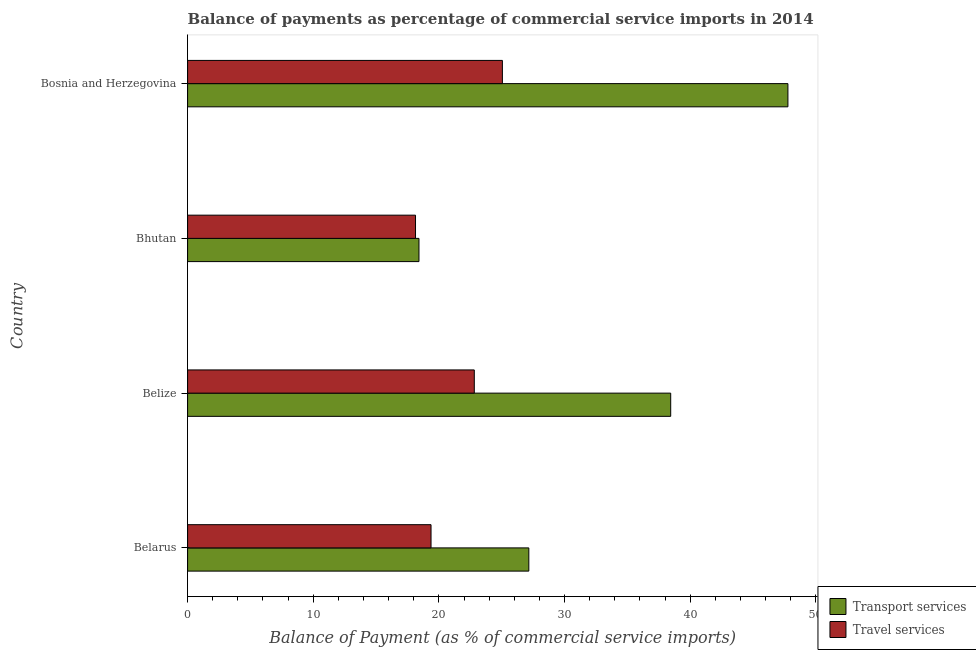How many different coloured bars are there?
Your answer should be very brief. 2. Are the number of bars per tick equal to the number of legend labels?
Your response must be concise. Yes. How many bars are there on the 4th tick from the top?
Ensure brevity in your answer.  2. How many bars are there on the 4th tick from the bottom?
Provide a short and direct response. 2. What is the label of the 3rd group of bars from the top?
Your answer should be compact. Belize. What is the balance of payments of transport services in Bosnia and Herzegovina?
Your answer should be very brief. 47.78. Across all countries, what is the maximum balance of payments of travel services?
Provide a short and direct response. 25.05. Across all countries, what is the minimum balance of payments of transport services?
Provide a short and direct response. 18.41. In which country was the balance of payments of transport services maximum?
Keep it short and to the point. Bosnia and Herzegovina. In which country was the balance of payments of transport services minimum?
Offer a terse response. Bhutan. What is the total balance of payments of transport services in the graph?
Offer a very short reply. 131.79. What is the difference between the balance of payments of transport services in Belarus and that in Bhutan?
Make the answer very short. 8.74. What is the difference between the balance of payments of transport services in Bhutan and the balance of payments of travel services in Bosnia and Herzegovina?
Your answer should be very brief. -6.64. What is the average balance of payments of travel services per country?
Provide a short and direct response. 21.34. What is the difference between the balance of payments of travel services and balance of payments of transport services in Belize?
Your answer should be very brief. -15.63. In how many countries, is the balance of payments of transport services greater than 18 %?
Offer a very short reply. 4. What is the ratio of the balance of payments of travel services in Belize to that in Bosnia and Herzegovina?
Your answer should be compact. 0.91. Is the difference between the balance of payments of travel services in Belize and Bosnia and Herzegovina greater than the difference between the balance of payments of transport services in Belize and Bosnia and Herzegovina?
Your response must be concise. Yes. What is the difference between the highest and the second highest balance of payments of travel services?
Provide a succinct answer. 2.24. What is the difference between the highest and the lowest balance of payments of transport services?
Offer a very short reply. 29.36. What does the 2nd bar from the top in Bhutan represents?
Ensure brevity in your answer.  Transport services. What does the 1st bar from the bottom in Bhutan represents?
Your response must be concise. Transport services. Are all the bars in the graph horizontal?
Give a very brief answer. Yes. Are the values on the major ticks of X-axis written in scientific E-notation?
Offer a terse response. No. Does the graph contain grids?
Provide a short and direct response. No. Where does the legend appear in the graph?
Provide a short and direct response. Bottom right. How many legend labels are there?
Give a very brief answer. 2. What is the title of the graph?
Provide a succinct answer. Balance of payments as percentage of commercial service imports in 2014. What is the label or title of the X-axis?
Offer a terse response. Balance of Payment (as % of commercial service imports). What is the Balance of Payment (as % of commercial service imports) in Transport services in Belarus?
Your answer should be compact. 27.16. What is the Balance of Payment (as % of commercial service imports) of Travel services in Belarus?
Your answer should be very brief. 19.37. What is the Balance of Payment (as % of commercial service imports) in Transport services in Belize?
Give a very brief answer. 38.45. What is the Balance of Payment (as % of commercial service imports) of Travel services in Belize?
Ensure brevity in your answer.  22.82. What is the Balance of Payment (as % of commercial service imports) in Transport services in Bhutan?
Ensure brevity in your answer.  18.41. What is the Balance of Payment (as % of commercial service imports) of Travel services in Bhutan?
Offer a very short reply. 18.14. What is the Balance of Payment (as % of commercial service imports) in Transport services in Bosnia and Herzegovina?
Provide a short and direct response. 47.78. What is the Balance of Payment (as % of commercial service imports) of Travel services in Bosnia and Herzegovina?
Provide a succinct answer. 25.05. Across all countries, what is the maximum Balance of Payment (as % of commercial service imports) in Transport services?
Your answer should be compact. 47.78. Across all countries, what is the maximum Balance of Payment (as % of commercial service imports) in Travel services?
Ensure brevity in your answer.  25.05. Across all countries, what is the minimum Balance of Payment (as % of commercial service imports) in Transport services?
Your response must be concise. 18.41. Across all countries, what is the minimum Balance of Payment (as % of commercial service imports) in Travel services?
Offer a very short reply. 18.14. What is the total Balance of Payment (as % of commercial service imports) in Transport services in the graph?
Provide a succinct answer. 131.79. What is the total Balance of Payment (as % of commercial service imports) of Travel services in the graph?
Keep it short and to the point. 85.38. What is the difference between the Balance of Payment (as % of commercial service imports) in Transport services in Belarus and that in Belize?
Provide a short and direct response. -11.29. What is the difference between the Balance of Payment (as % of commercial service imports) in Travel services in Belarus and that in Belize?
Ensure brevity in your answer.  -3.44. What is the difference between the Balance of Payment (as % of commercial service imports) of Transport services in Belarus and that in Bhutan?
Make the answer very short. 8.74. What is the difference between the Balance of Payment (as % of commercial service imports) of Travel services in Belarus and that in Bhutan?
Offer a very short reply. 1.23. What is the difference between the Balance of Payment (as % of commercial service imports) of Transport services in Belarus and that in Bosnia and Herzegovina?
Offer a terse response. -20.62. What is the difference between the Balance of Payment (as % of commercial service imports) in Travel services in Belarus and that in Bosnia and Herzegovina?
Provide a short and direct response. -5.68. What is the difference between the Balance of Payment (as % of commercial service imports) in Transport services in Belize and that in Bhutan?
Your response must be concise. 20.03. What is the difference between the Balance of Payment (as % of commercial service imports) of Travel services in Belize and that in Bhutan?
Keep it short and to the point. 4.68. What is the difference between the Balance of Payment (as % of commercial service imports) of Transport services in Belize and that in Bosnia and Herzegovina?
Keep it short and to the point. -9.33. What is the difference between the Balance of Payment (as % of commercial service imports) of Travel services in Belize and that in Bosnia and Herzegovina?
Provide a succinct answer. -2.24. What is the difference between the Balance of Payment (as % of commercial service imports) in Transport services in Bhutan and that in Bosnia and Herzegovina?
Your answer should be compact. -29.36. What is the difference between the Balance of Payment (as % of commercial service imports) in Travel services in Bhutan and that in Bosnia and Herzegovina?
Your response must be concise. -6.91. What is the difference between the Balance of Payment (as % of commercial service imports) in Transport services in Belarus and the Balance of Payment (as % of commercial service imports) in Travel services in Belize?
Provide a short and direct response. 4.34. What is the difference between the Balance of Payment (as % of commercial service imports) in Transport services in Belarus and the Balance of Payment (as % of commercial service imports) in Travel services in Bhutan?
Provide a short and direct response. 9.02. What is the difference between the Balance of Payment (as % of commercial service imports) in Transport services in Belarus and the Balance of Payment (as % of commercial service imports) in Travel services in Bosnia and Herzegovina?
Your answer should be compact. 2.1. What is the difference between the Balance of Payment (as % of commercial service imports) of Transport services in Belize and the Balance of Payment (as % of commercial service imports) of Travel services in Bhutan?
Ensure brevity in your answer.  20.31. What is the difference between the Balance of Payment (as % of commercial service imports) of Transport services in Belize and the Balance of Payment (as % of commercial service imports) of Travel services in Bosnia and Herzegovina?
Your answer should be very brief. 13.39. What is the difference between the Balance of Payment (as % of commercial service imports) in Transport services in Bhutan and the Balance of Payment (as % of commercial service imports) in Travel services in Bosnia and Herzegovina?
Offer a terse response. -6.64. What is the average Balance of Payment (as % of commercial service imports) in Transport services per country?
Give a very brief answer. 32.95. What is the average Balance of Payment (as % of commercial service imports) of Travel services per country?
Provide a short and direct response. 21.35. What is the difference between the Balance of Payment (as % of commercial service imports) of Transport services and Balance of Payment (as % of commercial service imports) of Travel services in Belarus?
Provide a short and direct response. 7.78. What is the difference between the Balance of Payment (as % of commercial service imports) of Transport services and Balance of Payment (as % of commercial service imports) of Travel services in Belize?
Make the answer very short. 15.63. What is the difference between the Balance of Payment (as % of commercial service imports) in Transport services and Balance of Payment (as % of commercial service imports) in Travel services in Bhutan?
Offer a very short reply. 0.27. What is the difference between the Balance of Payment (as % of commercial service imports) in Transport services and Balance of Payment (as % of commercial service imports) in Travel services in Bosnia and Herzegovina?
Your response must be concise. 22.72. What is the ratio of the Balance of Payment (as % of commercial service imports) in Transport services in Belarus to that in Belize?
Keep it short and to the point. 0.71. What is the ratio of the Balance of Payment (as % of commercial service imports) in Travel services in Belarus to that in Belize?
Give a very brief answer. 0.85. What is the ratio of the Balance of Payment (as % of commercial service imports) of Transport services in Belarus to that in Bhutan?
Offer a terse response. 1.47. What is the ratio of the Balance of Payment (as % of commercial service imports) of Travel services in Belarus to that in Bhutan?
Your answer should be compact. 1.07. What is the ratio of the Balance of Payment (as % of commercial service imports) of Transport services in Belarus to that in Bosnia and Herzegovina?
Offer a terse response. 0.57. What is the ratio of the Balance of Payment (as % of commercial service imports) in Travel services in Belarus to that in Bosnia and Herzegovina?
Your answer should be very brief. 0.77. What is the ratio of the Balance of Payment (as % of commercial service imports) of Transport services in Belize to that in Bhutan?
Provide a succinct answer. 2.09. What is the ratio of the Balance of Payment (as % of commercial service imports) in Travel services in Belize to that in Bhutan?
Ensure brevity in your answer.  1.26. What is the ratio of the Balance of Payment (as % of commercial service imports) of Transport services in Belize to that in Bosnia and Herzegovina?
Your response must be concise. 0.8. What is the ratio of the Balance of Payment (as % of commercial service imports) in Travel services in Belize to that in Bosnia and Herzegovina?
Keep it short and to the point. 0.91. What is the ratio of the Balance of Payment (as % of commercial service imports) in Transport services in Bhutan to that in Bosnia and Herzegovina?
Your answer should be compact. 0.39. What is the ratio of the Balance of Payment (as % of commercial service imports) in Travel services in Bhutan to that in Bosnia and Herzegovina?
Provide a succinct answer. 0.72. What is the difference between the highest and the second highest Balance of Payment (as % of commercial service imports) in Transport services?
Provide a succinct answer. 9.33. What is the difference between the highest and the second highest Balance of Payment (as % of commercial service imports) in Travel services?
Offer a very short reply. 2.24. What is the difference between the highest and the lowest Balance of Payment (as % of commercial service imports) of Transport services?
Ensure brevity in your answer.  29.36. What is the difference between the highest and the lowest Balance of Payment (as % of commercial service imports) in Travel services?
Make the answer very short. 6.91. 